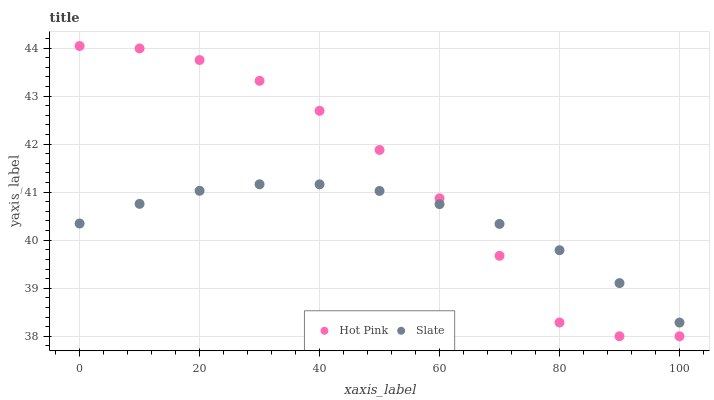Does Slate have the minimum area under the curve?
Answer yes or no. Yes. Does Hot Pink have the maximum area under the curve?
Answer yes or no. Yes. Does Hot Pink have the minimum area under the curve?
Answer yes or no. No. Is Slate the smoothest?
Answer yes or no. Yes. Is Hot Pink the roughest?
Answer yes or no. Yes. Is Hot Pink the smoothest?
Answer yes or no. No. Does Hot Pink have the lowest value?
Answer yes or no. Yes. Does Hot Pink have the highest value?
Answer yes or no. Yes. Does Slate intersect Hot Pink?
Answer yes or no. Yes. Is Slate less than Hot Pink?
Answer yes or no. No. Is Slate greater than Hot Pink?
Answer yes or no. No. 